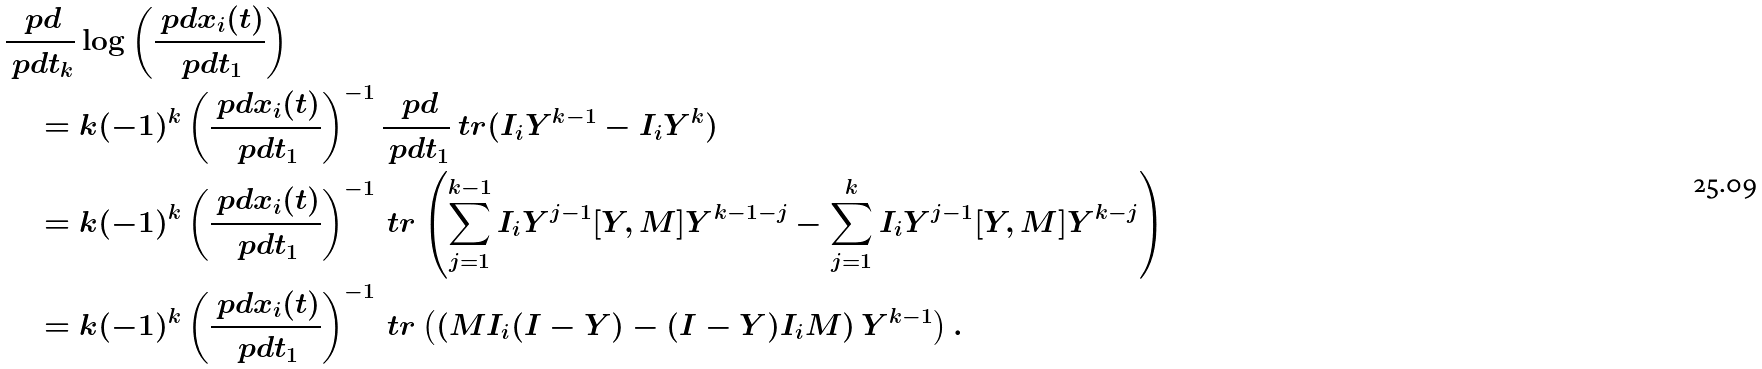<formula> <loc_0><loc_0><loc_500><loc_500>& \frac { \ p d } { \ p d t _ { k } } \log \left ( \frac { \ p d x _ { i } ( t ) } { \ p d t _ { 1 } } \right ) \\ & \quad = k ( - 1 ) ^ { k } \left ( \frac { \ p d x _ { i } ( t ) } { \ p d t _ { 1 } } \right ) ^ { - 1 } \frac { \ p d } { \ p d t _ { 1 } } \ t r ( I _ { i } Y ^ { k - 1 } - I _ { i } Y ^ { k } ) \\ & \quad = k ( - 1 ) ^ { k } \left ( \frac { \ p d x _ { i } ( t ) } { \ p d t _ { 1 } } \right ) ^ { - 1 } \ t r \left ( \sum _ { j = 1 } ^ { k - 1 } I _ { i } Y ^ { j - 1 } [ Y , M ] Y ^ { k - 1 - j } - \sum _ { j = 1 } ^ { k } I _ { i } Y ^ { j - 1 } [ Y , M ] Y ^ { k - j } \right ) \\ & \quad = k ( - 1 ) ^ { k } \left ( \frac { \ p d x _ { i } ( t ) } { \ p d t _ { 1 } } \right ) ^ { - 1 } \ t r \left ( \left ( M I _ { i } ( I - Y ) - ( I - Y ) I _ { i } M \right ) Y ^ { k - 1 } \right ) .</formula> 